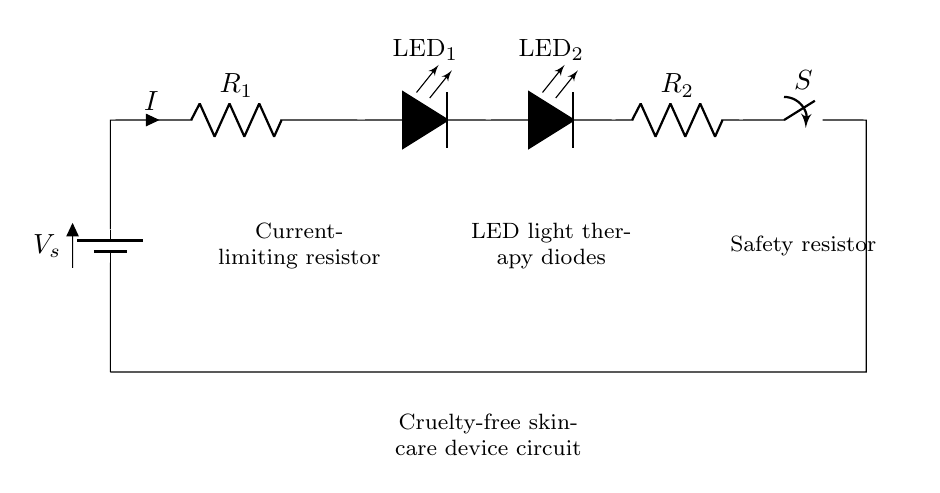What is the total number of LEDs in the circuit? The circuit shows two LED components, which are connected in series as indicated by the visual representation.
Answer: 2 What is the function of resistor R1? Resistor R1 is labeled as a current-limiting resistor, which means its purpose is to limit the flow of current through the LEDs to safe levels.
Answer: Current-limiting resistor What component is labeled S in the circuit? S is identified as a switch in the diagram, which is used to control the flow of electricity in the circuit by opening or closing.
Answer: Switch Which component protects against excess current? The safety resistor labeled R2 is used to protect the circuit against excess current that could potentially damage the LEDs or other components.
Answer: Safety resistor What type of circuit is depicted here? This circuit specifically represents a series circuit because all components, including the battery, resistors, and LEDs, are connected end-to-end in a single path for current flow.
Answer: Series circuit What happens if resistor R1 is removed from the circuit? Without R1, there would be no current-limiting control, leading to potentially excessive current going through the LEDs, likely causing them to burn out or get damaged.
Answer: LEDs burn out What type of application is this circuit intended for? The diagram indicates that this circuit is for a cruelty-free skincare device, specifically for LED light therapy, which aligns with ethical skincare practices.
Answer: Skincare device 